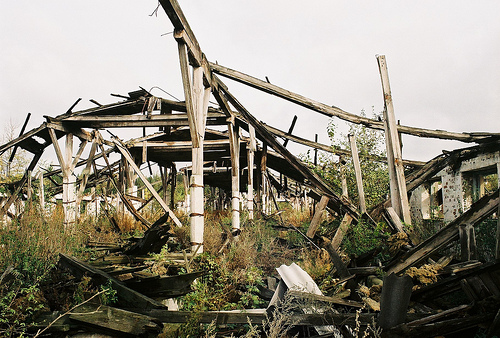<image>
Can you confirm if the beam is on the column? Yes. Looking at the image, I can see the beam is positioned on top of the column, with the column providing support. 